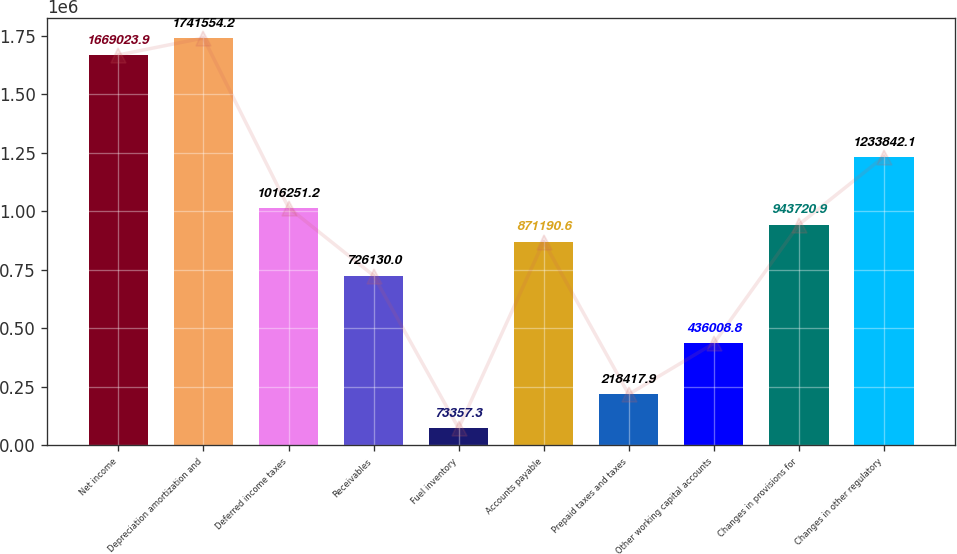Convert chart to OTSL. <chart><loc_0><loc_0><loc_500><loc_500><bar_chart><fcel>Net income<fcel>Depreciation amortization and<fcel>Deferred income taxes<fcel>Receivables<fcel>Fuel inventory<fcel>Accounts payable<fcel>Prepaid taxes and taxes<fcel>Other working capital accounts<fcel>Changes in provisions for<fcel>Changes in other regulatory<nl><fcel>1.66902e+06<fcel>1.74155e+06<fcel>1.01625e+06<fcel>726130<fcel>73357.3<fcel>871191<fcel>218418<fcel>436009<fcel>943721<fcel>1.23384e+06<nl></chart> 